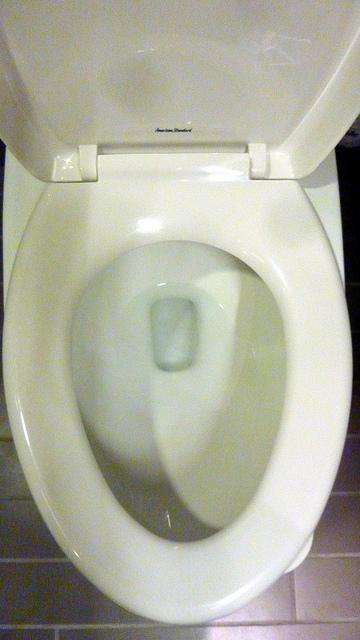What color is the tile on the floor?
Quick response, please. Brown. Has the toilet been used?
Answer briefly. No. Is the lid up?
Short answer required. Yes. 